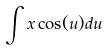<formula> <loc_0><loc_0><loc_500><loc_500>\int x \cos ( u ) d u</formula> 